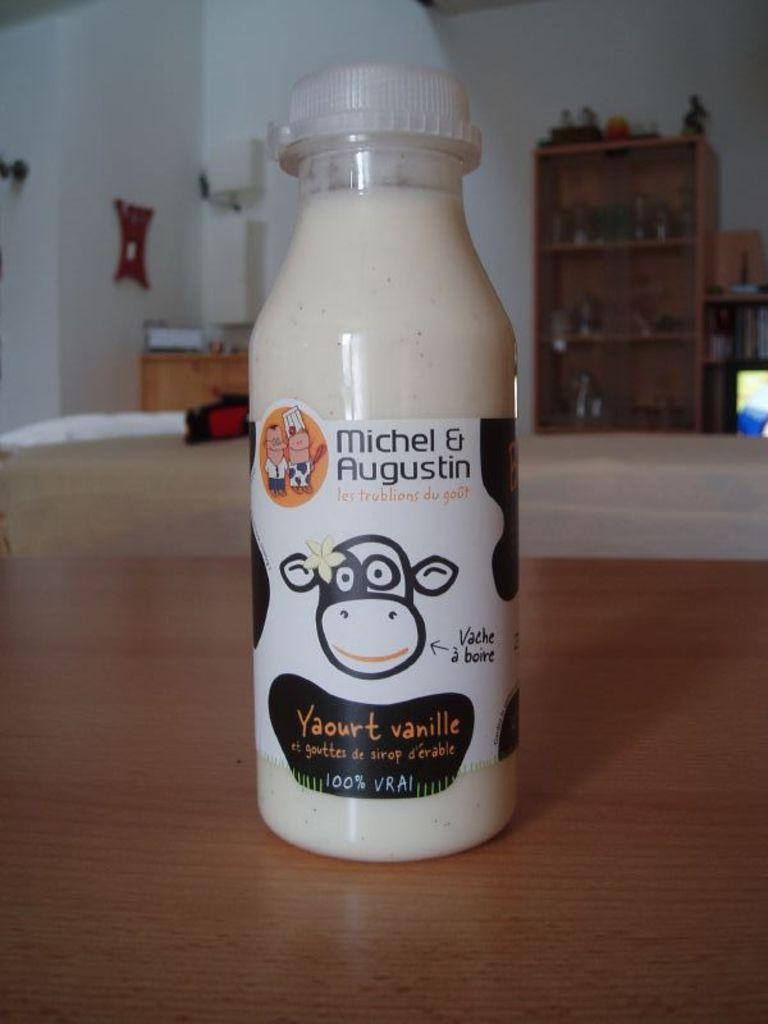Describe this image in one or two sentences. In this image, we can see a bottle there is a sticker on it. That is placed on a wooden table. Background we can see right side ,some cupboard few items are placed in it. On left side, there is a cupboard, there are few items are placed. Here there is a white color piece and some hanging and wall we can see. At the right side, the screen is viewing. 